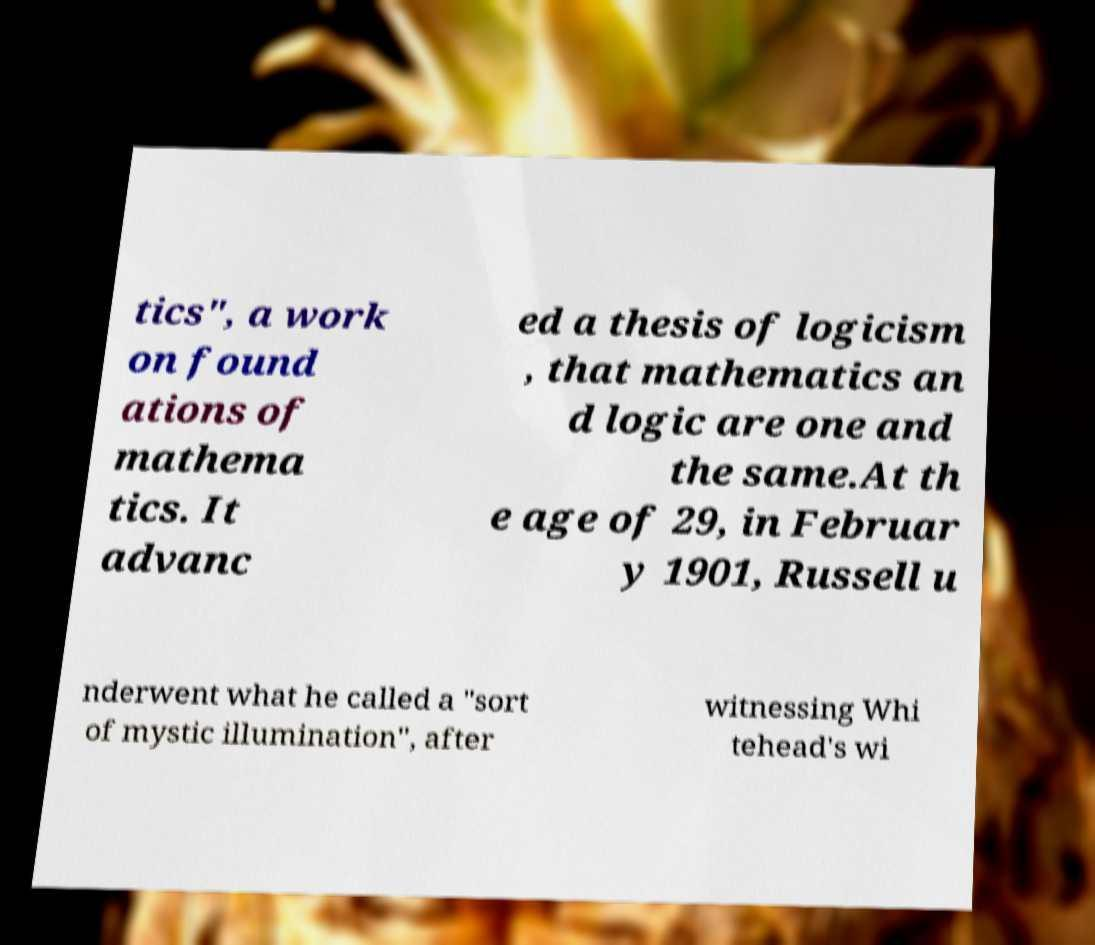Please identify and transcribe the text found in this image. tics", a work on found ations of mathema tics. It advanc ed a thesis of logicism , that mathematics an d logic are one and the same.At th e age of 29, in Februar y 1901, Russell u nderwent what he called a "sort of mystic illumination", after witnessing Whi tehead's wi 